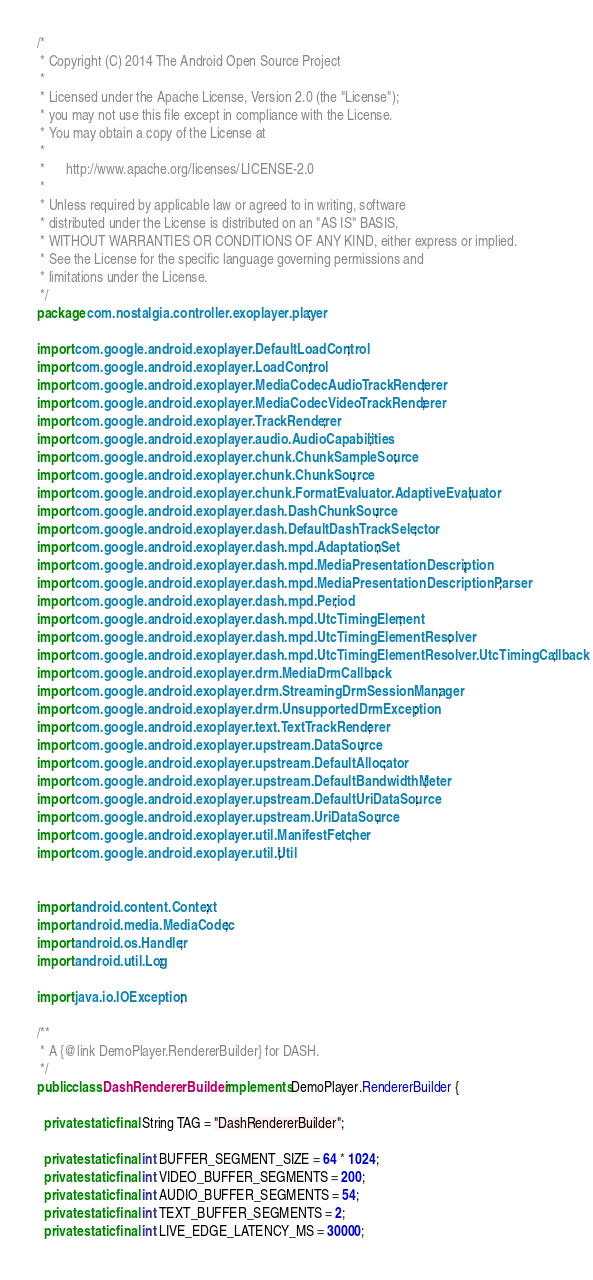<code> <loc_0><loc_0><loc_500><loc_500><_Java_>/*
 * Copyright (C) 2014 The Android Open Source Project
 *
 * Licensed under the Apache License, Version 2.0 (the "License");
 * you may not use this file except in compliance with the License.
 * You may obtain a copy of the License at
 *
 *      http://www.apache.org/licenses/LICENSE-2.0
 *
 * Unless required by applicable law or agreed to in writing, software
 * distributed under the License is distributed on an "AS IS" BASIS,
 * WITHOUT WARRANTIES OR CONDITIONS OF ANY KIND, either express or implied.
 * See the License for the specific language governing permissions and
 * limitations under the License.
 */
package com.nostalgia.controller.exoplayer.player;

import com.google.android.exoplayer.DefaultLoadControl;
import com.google.android.exoplayer.LoadControl;
import com.google.android.exoplayer.MediaCodecAudioTrackRenderer;
import com.google.android.exoplayer.MediaCodecVideoTrackRenderer;
import com.google.android.exoplayer.TrackRenderer;
import com.google.android.exoplayer.audio.AudioCapabilities;
import com.google.android.exoplayer.chunk.ChunkSampleSource;
import com.google.android.exoplayer.chunk.ChunkSource;
import com.google.android.exoplayer.chunk.FormatEvaluator.AdaptiveEvaluator;
import com.google.android.exoplayer.dash.DashChunkSource;
import com.google.android.exoplayer.dash.DefaultDashTrackSelector;
import com.google.android.exoplayer.dash.mpd.AdaptationSet;
import com.google.android.exoplayer.dash.mpd.MediaPresentationDescription;
import com.google.android.exoplayer.dash.mpd.MediaPresentationDescriptionParser;
import com.google.android.exoplayer.dash.mpd.Period;
import com.google.android.exoplayer.dash.mpd.UtcTimingElement;
import com.google.android.exoplayer.dash.mpd.UtcTimingElementResolver;
import com.google.android.exoplayer.dash.mpd.UtcTimingElementResolver.UtcTimingCallback;
import com.google.android.exoplayer.drm.MediaDrmCallback;
import com.google.android.exoplayer.drm.StreamingDrmSessionManager;
import com.google.android.exoplayer.drm.UnsupportedDrmException;
import com.google.android.exoplayer.text.TextTrackRenderer;
import com.google.android.exoplayer.upstream.DataSource;
import com.google.android.exoplayer.upstream.DefaultAllocator;
import com.google.android.exoplayer.upstream.DefaultBandwidthMeter;
import com.google.android.exoplayer.upstream.DefaultUriDataSource;
import com.google.android.exoplayer.upstream.UriDataSource;
import com.google.android.exoplayer.util.ManifestFetcher;
import com.google.android.exoplayer.util.Util;


import android.content.Context;
import android.media.MediaCodec;
import android.os.Handler;
import android.util.Log;

import java.io.IOException;

/**
 * A {@link DemoPlayer.RendererBuilder} for DASH.
 */
public class DashRendererBuilder implements DemoPlayer.RendererBuilder {

  private static final String TAG = "DashRendererBuilder";

  private static final int BUFFER_SEGMENT_SIZE = 64 * 1024;
  private static final int VIDEO_BUFFER_SEGMENTS = 200;
  private static final int AUDIO_BUFFER_SEGMENTS = 54;
  private static final int TEXT_BUFFER_SEGMENTS = 2;
  private static final int LIVE_EDGE_LATENCY_MS = 30000;
</code> 